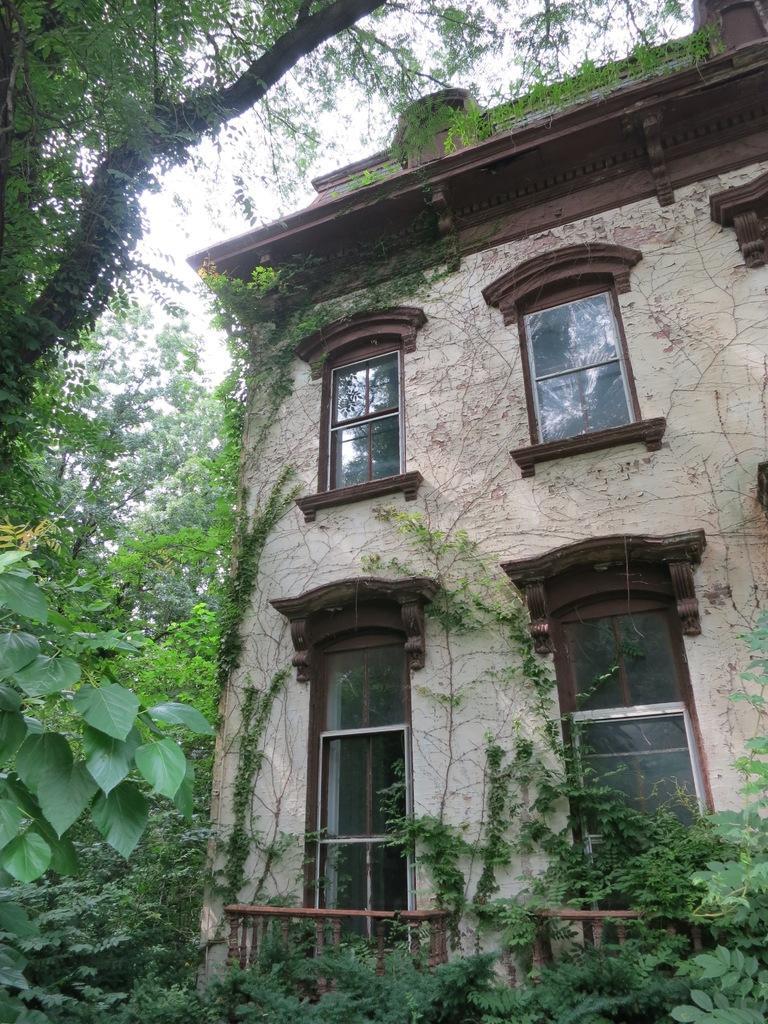Please provide a concise description of this image. In this image there are trees and leaves on the left corner. There is a building with windows, wooden railing and trees on the right corner. There is sky at the top. 